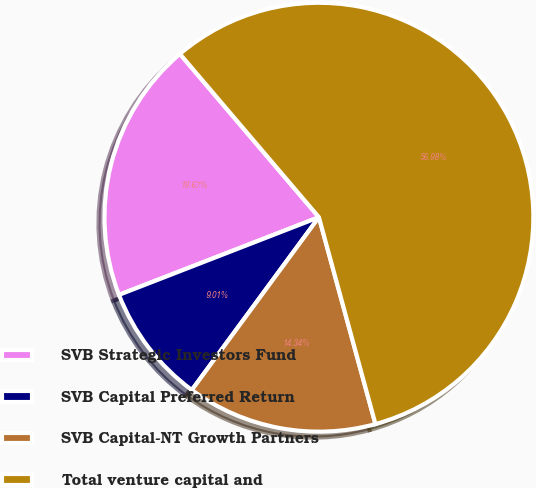<chart> <loc_0><loc_0><loc_500><loc_500><pie_chart><fcel>SVB Strategic Investors Fund<fcel>SVB Capital Preferred Return<fcel>SVB Capital-NT Growth Partners<fcel>Total venture capital and<nl><fcel>19.67%<fcel>9.01%<fcel>14.34%<fcel>56.97%<nl></chart> 